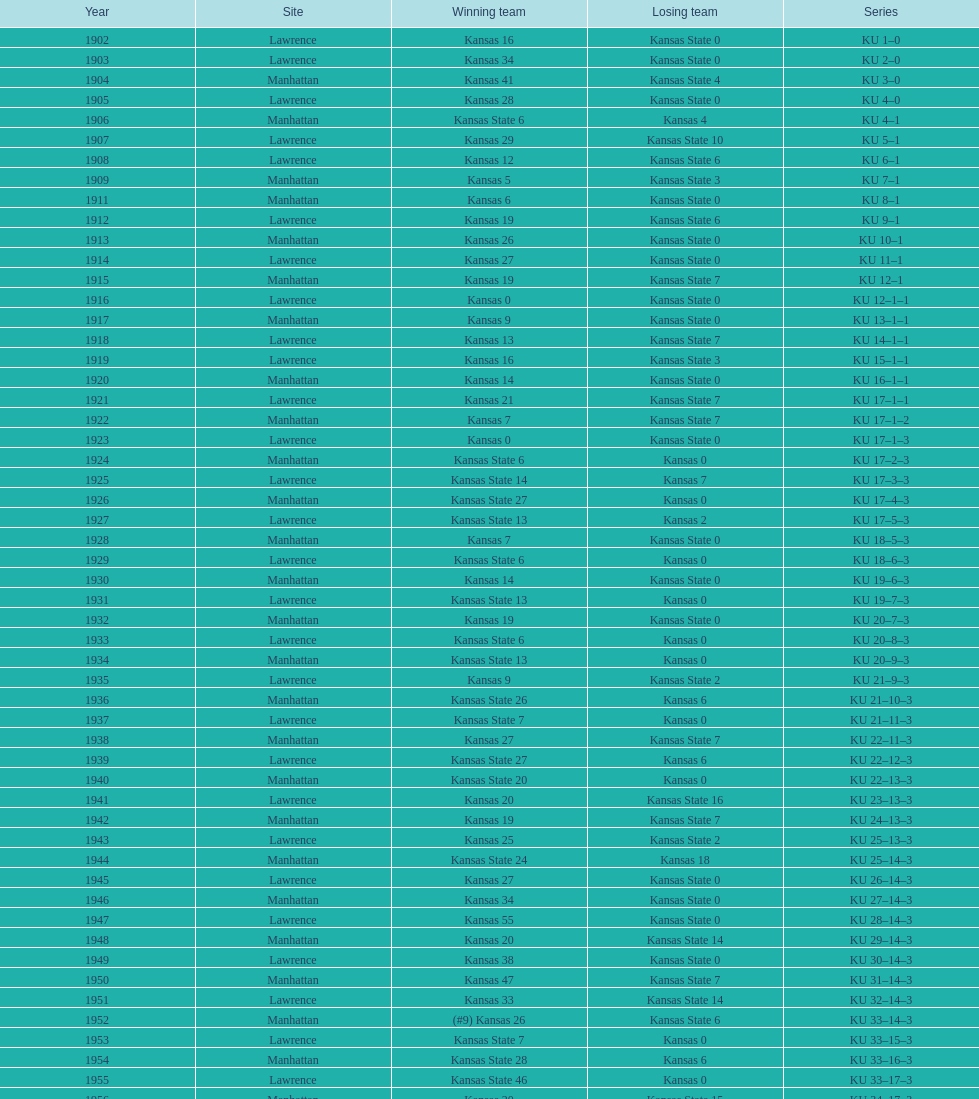From 1902 to 1968, in how many games did kansas state remain scoreless against kansas? 23. 